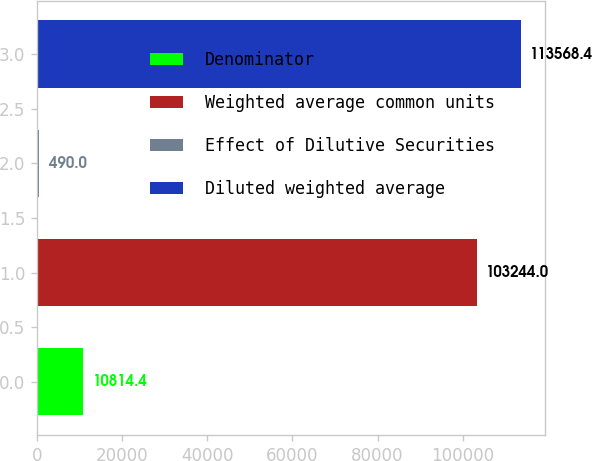<chart> <loc_0><loc_0><loc_500><loc_500><bar_chart><fcel>Denominator<fcel>Weighted average common units<fcel>Effect of Dilutive Securities<fcel>Diluted weighted average<nl><fcel>10814.4<fcel>103244<fcel>490<fcel>113568<nl></chart> 